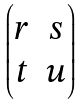Convert formula to latex. <formula><loc_0><loc_0><loc_500><loc_500>\begin{pmatrix} r & s \\ t & u \end{pmatrix}</formula> 